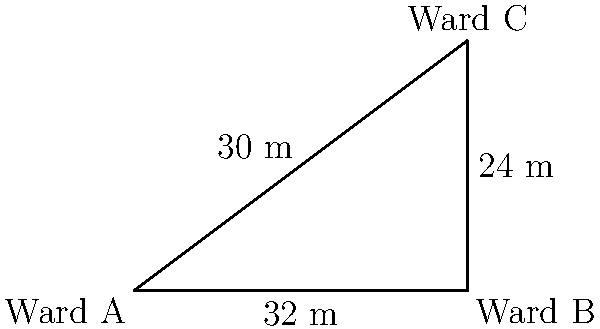A nurse needs to walk from Ward A to Ward C in a hospital. The layout of the wards forms a right-angled triangle as shown in the diagram. If it takes the nurse 25 seconds to walk from Ward A to Ward C, calculate the velocity vector of the nurse's movement. To find the velocity vector, we need to follow these steps:

1) First, calculate the displacement vector:
   - The displacement is from Ward A to Ward C
   - We can represent this as a vector with components (x, y)
   - From the diagram, x = 4 units and y = 3 units
   - Each unit represents 8 meters (32 m / 4 units = 8 m/unit)
   - So, the actual displacement vector is (32 m, 24 m)

2) Calculate the magnitude of the displacement:
   $$|\vec{d}| = \sqrt{32^2 + 24^2} = \sqrt{1024 + 576} = \sqrt{1600} = 40 \text{ m}$$

3) The velocity vector is the displacement vector divided by time:
   $$\vec{v} = \frac{\vec{d}}{t} = \frac{(32, 24)}{25} = (1.28, 0.96) \text{ m/s}$$

4) To verify, we can calculate the magnitude of the velocity:
   $$|\vec{v}| = \frac{|\vec{d}|}{t} = \frac{40 \text{ m}}{25 \text{ s}} = 1.6 \text{ m/s}$$

   Which is equal to $\sqrt{1.28^2 + 0.96^2} = \sqrt{2.56} = 1.6 \text{ m/s}$

Therefore, the velocity vector of the nurse's movement is (1.28, 0.96) m/s.
Answer: (1.28, 0.96) m/s 